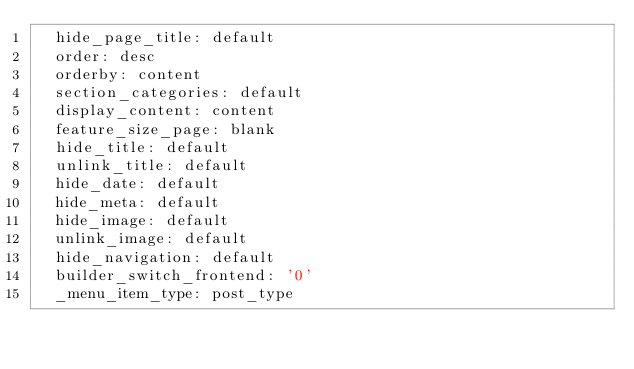<code> <loc_0><loc_0><loc_500><loc_500><_HTML_>  hide_page_title: default
  order: desc
  orderby: content
  section_categories: default
  display_content: content
  feature_size_page: blank
  hide_title: default
  unlink_title: default
  hide_date: default
  hide_meta: default
  hide_image: default
  unlink_image: default
  hide_navigation: default
  builder_switch_frontend: '0'
  _menu_item_type: post_type</code> 